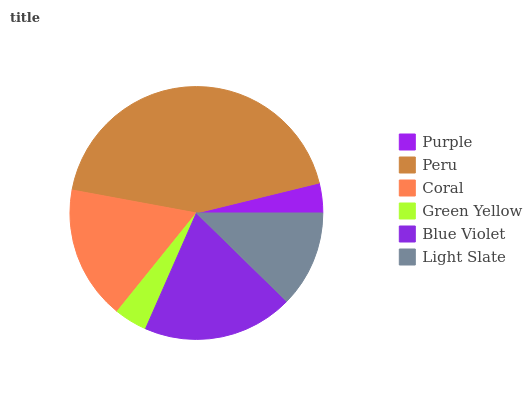Is Purple the minimum?
Answer yes or no. Yes. Is Peru the maximum?
Answer yes or no. Yes. Is Coral the minimum?
Answer yes or no. No. Is Coral the maximum?
Answer yes or no. No. Is Peru greater than Coral?
Answer yes or no. Yes. Is Coral less than Peru?
Answer yes or no. Yes. Is Coral greater than Peru?
Answer yes or no. No. Is Peru less than Coral?
Answer yes or no. No. Is Coral the high median?
Answer yes or no. Yes. Is Light Slate the low median?
Answer yes or no. Yes. Is Light Slate the high median?
Answer yes or no. No. Is Purple the low median?
Answer yes or no. No. 